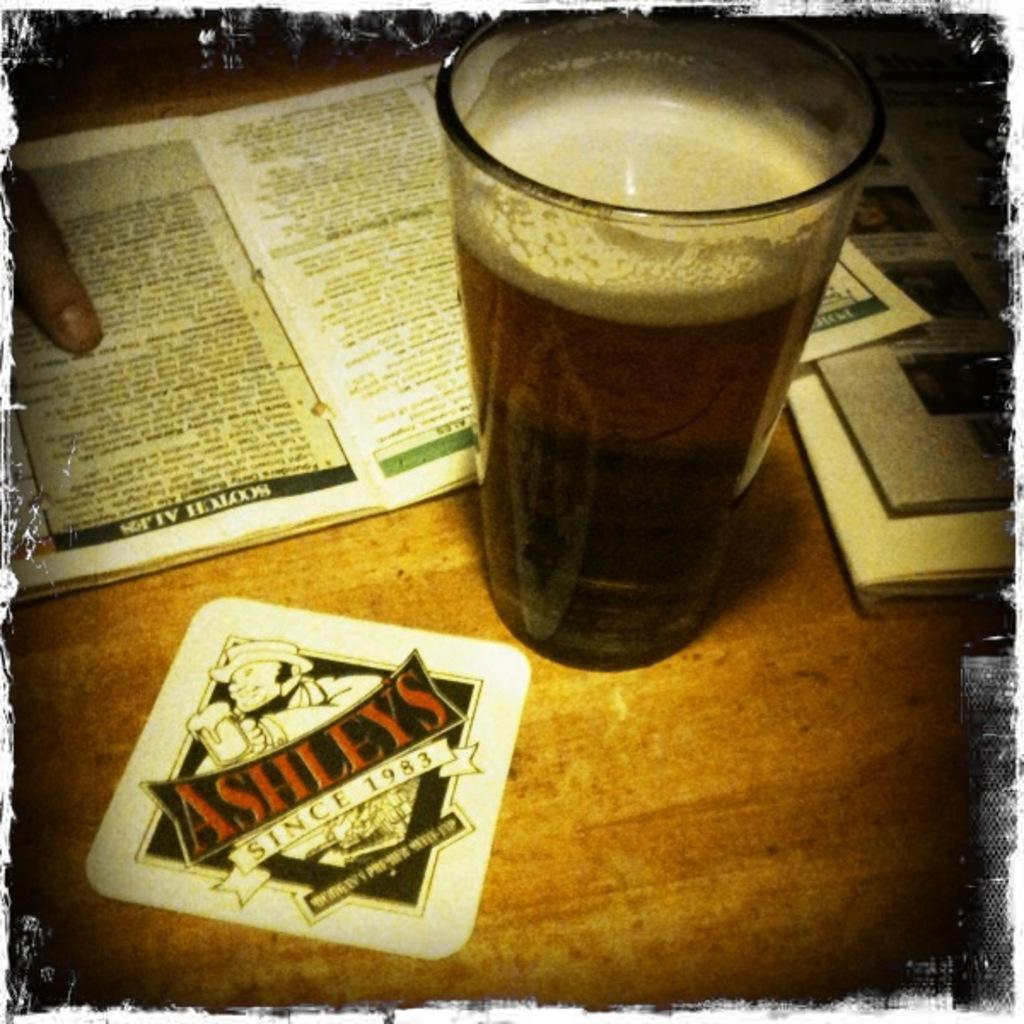<image>
Relay a brief, clear account of the picture shown. glass of beer sitting on a table at Ashleys 